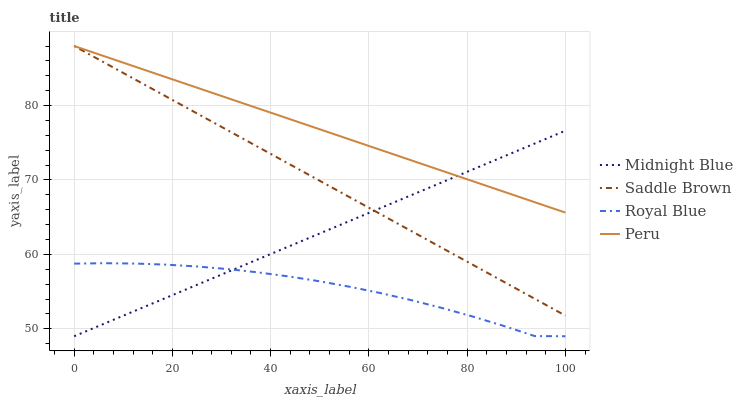Does Royal Blue have the minimum area under the curve?
Answer yes or no. Yes. Does Peru have the maximum area under the curve?
Answer yes or no. Yes. Does Midnight Blue have the minimum area under the curve?
Answer yes or no. No. Does Midnight Blue have the maximum area under the curve?
Answer yes or no. No. Is Saddle Brown the smoothest?
Answer yes or no. Yes. Is Royal Blue the roughest?
Answer yes or no. Yes. Is Midnight Blue the smoothest?
Answer yes or no. No. Is Midnight Blue the roughest?
Answer yes or no. No. Does Royal Blue have the lowest value?
Answer yes or no. Yes. Does Peru have the lowest value?
Answer yes or no. No. Does Saddle Brown have the highest value?
Answer yes or no. Yes. Does Midnight Blue have the highest value?
Answer yes or no. No. Is Royal Blue less than Saddle Brown?
Answer yes or no. Yes. Is Peru greater than Royal Blue?
Answer yes or no. Yes. Does Midnight Blue intersect Saddle Brown?
Answer yes or no. Yes. Is Midnight Blue less than Saddle Brown?
Answer yes or no. No. Is Midnight Blue greater than Saddle Brown?
Answer yes or no. No. Does Royal Blue intersect Saddle Brown?
Answer yes or no. No. 